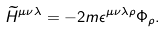Convert formula to latex. <formula><loc_0><loc_0><loc_500><loc_500>\widetilde { H } ^ { \mu \nu \lambda } = - 2 m \epsilon ^ { \mu \nu \lambda \rho } \Phi _ { \rho } .</formula> 